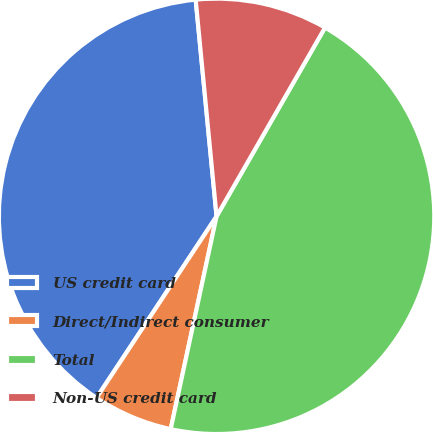<chart> <loc_0><loc_0><loc_500><loc_500><pie_chart><fcel>US credit card<fcel>Direct/Indirect consumer<fcel>Total<fcel>Non-US credit card<nl><fcel>39.17%<fcel>5.92%<fcel>45.08%<fcel>9.83%<nl></chart> 